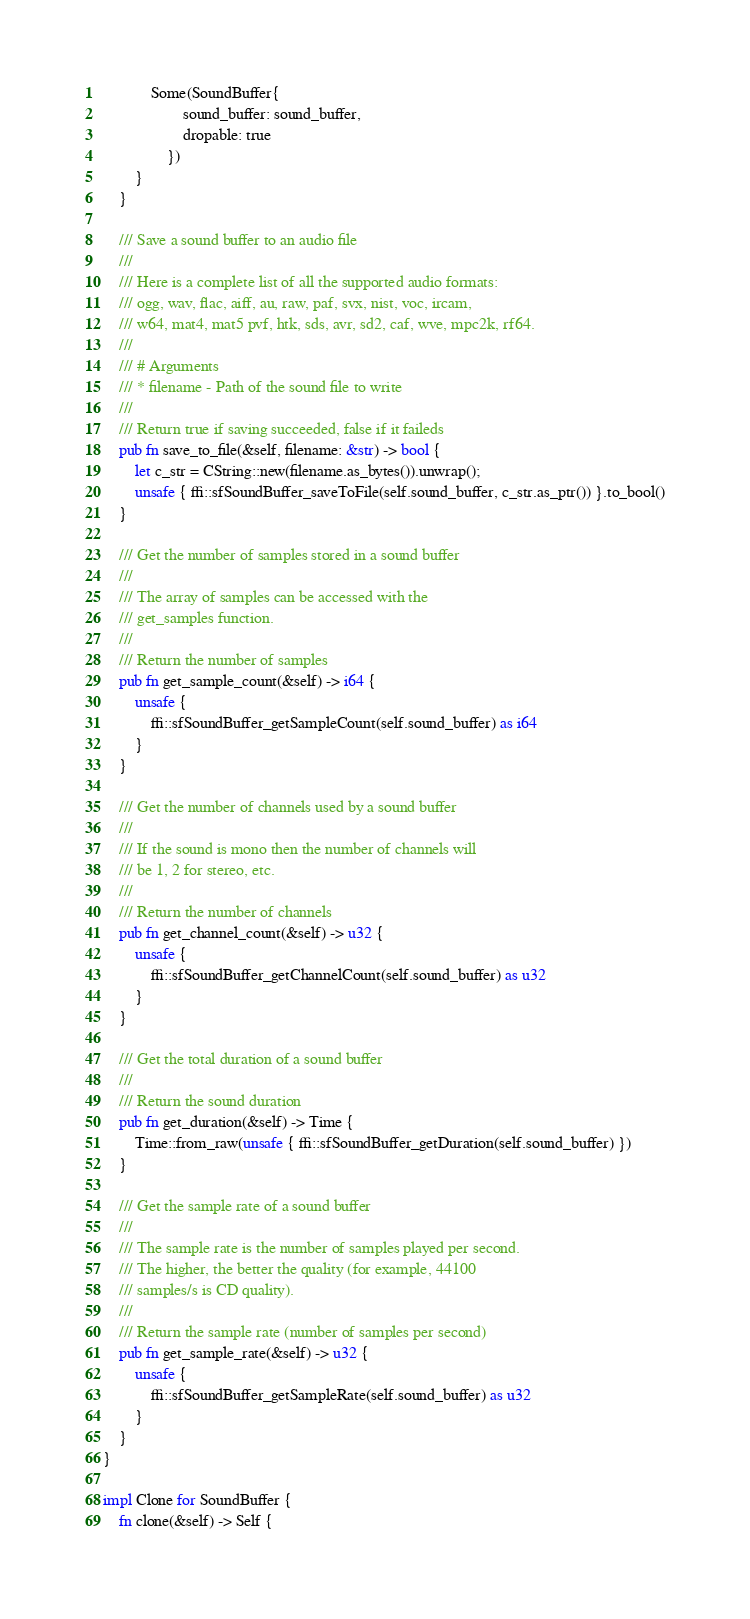<code> <loc_0><loc_0><loc_500><loc_500><_Rust_>            Some(SoundBuffer{
                    sound_buffer: sound_buffer,
                    dropable: true
                })
        }
    }

    /// Save a sound buffer to an audio file
    ///
    /// Here is a complete list of all the supported audio formats:
    /// ogg, wav, flac, aiff, au, raw, paf, svx, nist, voc, ircam,
    /// w64, mat4, mat5 pvf, htk, sds, avr, sd2, caf, wve, mpc2k, rf64.
    ///
    /// # Arguments
    /// * filename - Path of the sound file to write
    ///
    /// Return true if saving succeeded, false if it faileds
    pub fn save_to_file(&self, filename: &str) -> bool {
        let c_str = CString::new(filename.as_bytes()).unwrap();
        unsafe { ffi::sfSoundBuffer_saveToFile(self.sound_buffer, c_str.as_ptr()) }.to_bool()
    }

    /// Get the number of samples stored in a sound buffer
    ///
    /// The array of samples can be accessed with the
    /// get_samples function.
    ///
    /// Return the number of samples
    pub fn get_sample_count(&self) -> i64 {
        unsafe {
            ffi::sfSoundBuffer_getSampleCount(self.sound_buffer) as i64
        }
    }

    /// Get the number of channels used by a sound buffer
    ///
    /// If the sound is mono then the number of channels will
    /// be 1, 2 for stereo, etc.
    ///
    /// Return the number of channels
    pub fn get_channel_count(&self) -> u32 {
        unsafe {
            ffi::sfSoundBuffer_getChannelCount(self.sound_buffer) as u32
        }
    }

    /// Get the total duration of a sound buffer
    ///
    /// Return the sound duration
    pub fn get_duration(&self) -> Time {
        Time::from_raw(unsafe { ffi::sfSoundBuffer_getDuration(self.sound_buffer) })
    }

    /// Get the sample rate of a sound buffer
    ///
    /// The sample rate is the number of samples played per second.
    /// The higher, the better the quality (for example, 44100
    /// samples/s is CD quality).
    ///
    /// Return the sample rate (number of samples per second)
    pub fn get_sample_rate(&self) -> u32 {
        unsafe {
            ffi::sfSoundBuffer_getSampleRate(self.sound_buffer) as u32
        }
    }
}

impl Clone for SoundBuffer {
    fn clone(&self) -> Self {</code> 